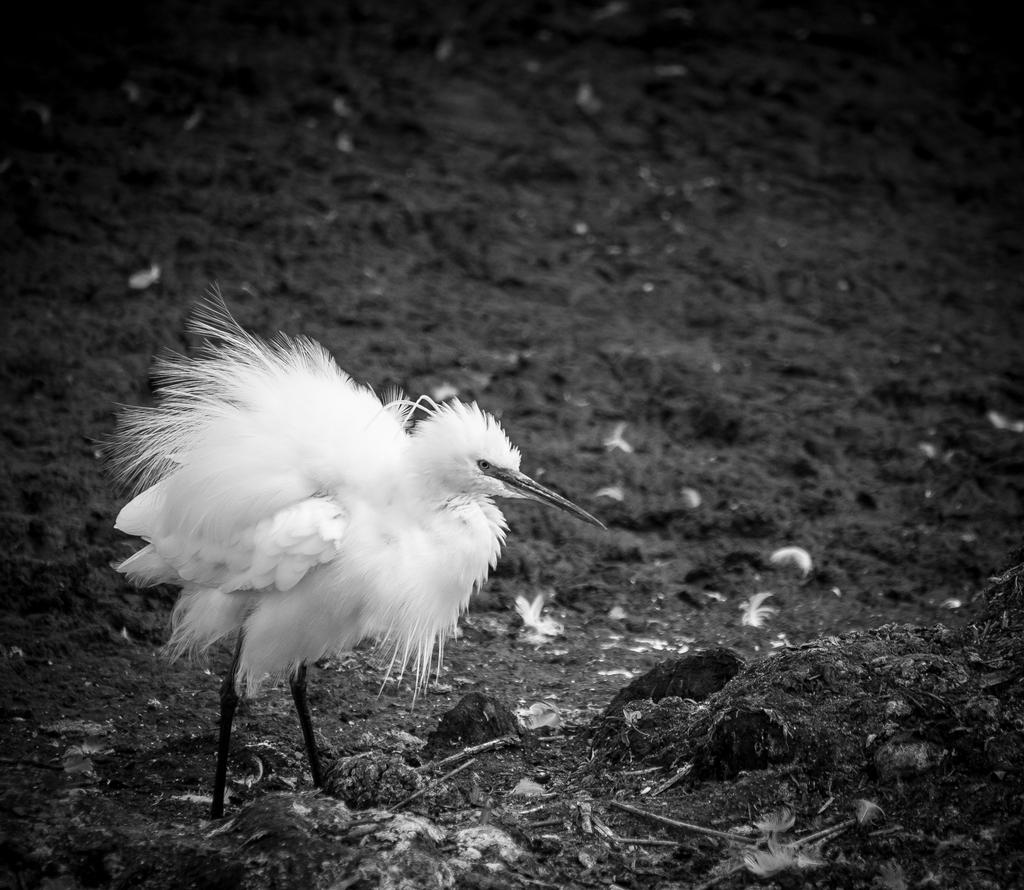What type of animal is in the image? There is a bird in the image. Where is the bird located in relation to the image? The bird is in the front of the image. What type of surface is visible at the bottom of the image? There is soil at the bottom of the image. What is the color scheme of the image? The image is black and white. What type of underwear is the bird wearing in the image? There is no underwear present in the image, as birds do not wear clothing. 